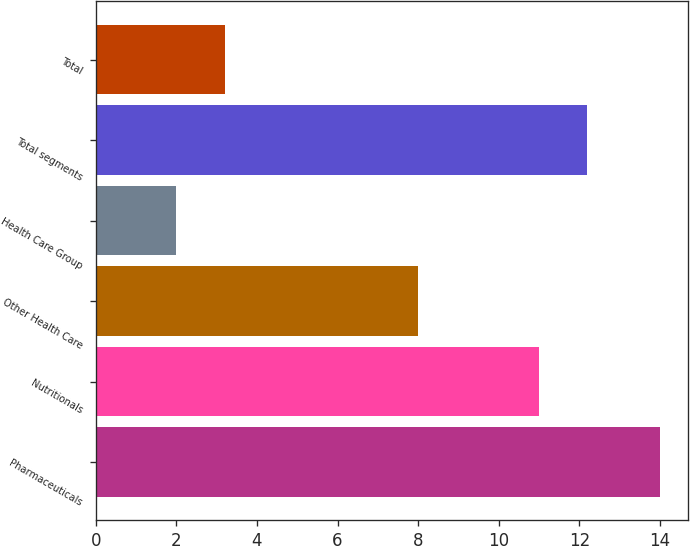Convert chart. <chart><loc_0><loc_0><loc_500><loc_500><bar_chart><fcel>Pharmaceuticals<fcel>Nutritionals<fcel>Other Health Care<fcel>Health Care Group<fcel>Total segments<fcel>Total<nl><fcel>14<fcel>11<fcel>8<fcel>2<fcel>12.2<fcel>3.2<nl></chart> 